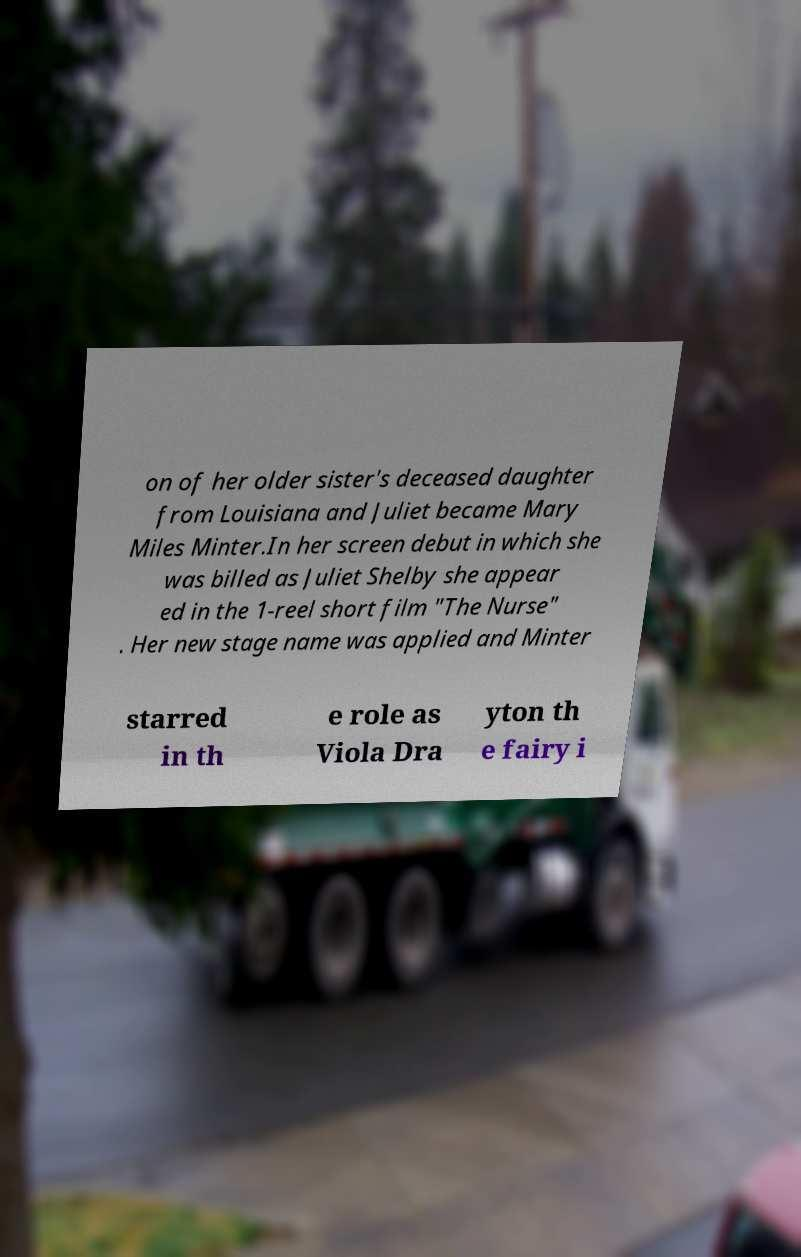Can you read and provide the text displayed in the image?This photo seems to have some interesting text. Can you extract and type it out for me? on of her older sister's deceased daughter from Louisiana and Juliet became Mary Miles Minter.In her screen debut in which she was billed as Juliet Shelby she appear ed in the 1-reel short film "The Nurse" . Her new stage name was applied and Minter starred in th e role as Viola Dra yton th e fairy i 